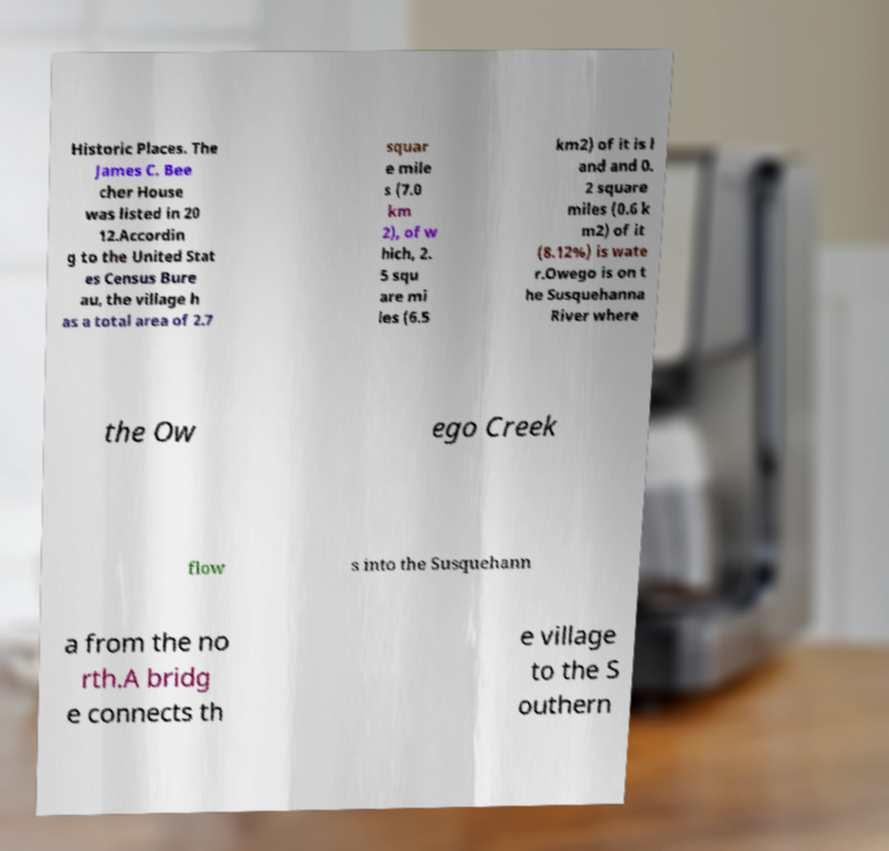Could you extract and type out the text from this image? Historic Places. The James C. Bee cher House was listed in 20 12.Accordin g to the United Stat es Census Bure au, the village h as a total area of 2.7 squar e mile s (7.0 km 2), of w hich, 2. 5 squ are mi les (6.5 km2) of it is l and and 0. 2 square miles (0.6 k m2) of it (8.12%) is wate r.Owego is on t he Susquehanna River where the Ow ego Creek flow s into the Susquehann a from the no rth.A bridg e connects th e village to the S outhern 